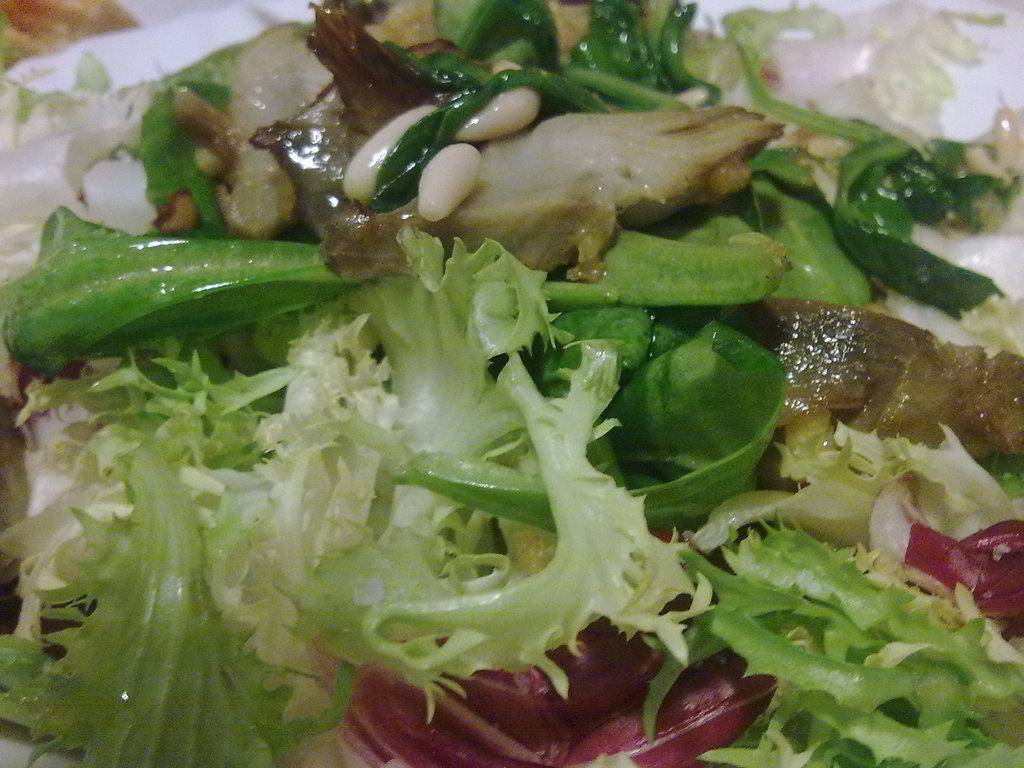What can be seen in the image? There is food visible in the image. Where is the horse sitting on the throne in the image? There is no horse or throne present in the image; it only features food. 